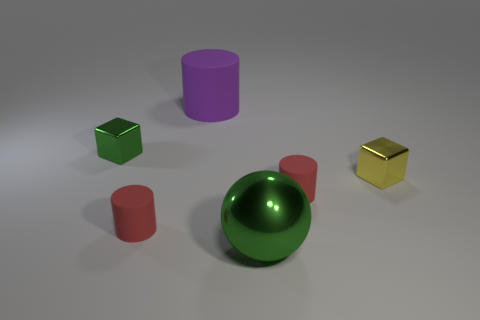There is a green thing that is the same material as the sphere; what is its size?
Keep it short and to the point. Small. What number of tiny objects are either brown shiny objects or yellow metal cubes?
Provide a succinct answer. 1. There is a block right of the red rubber thing that is on the left side of the metal thing in front of the yellow cube; what size is it?
Your answer should be very brief. Small. How many yellow metallic cubes have the same size as the sphere?
Provide a short and direct response. 0. How many things are either small red metal blocks or red rubber objects right of the purple cylinder?
Offer a very short reply. 1. The large shiny object has what shape?
Keep it short and to the point. Sphere. The other metal cube that is the same size as the green metallic block is what color?
Your answer should be compact. Yellow. How many red objects are tiny blocks or small things?
Keep it short and to the point. 2. Are there more yellow blocks than things?
Offer a very short reply. No. Do the shiny thing in front of the tiny yellow metal block and the matte thing right of the purple matte thing have the same size?
Offer a terse response. No. 